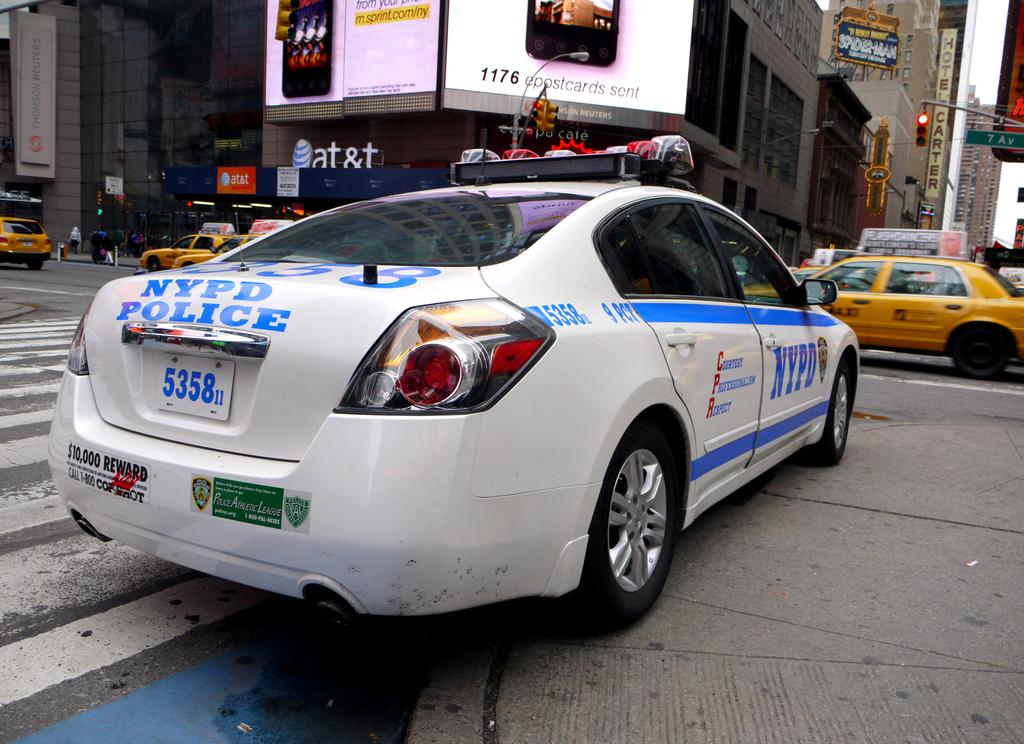<image>
Provide a brief description of the given image. An NYPD car facing an AT&T store and a cab. 